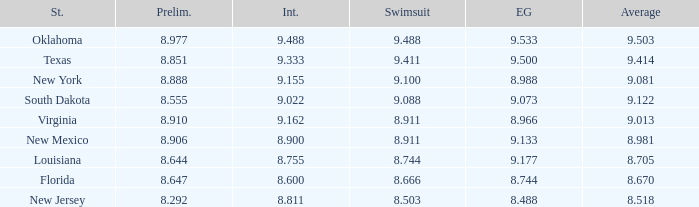 what's the evening gown where state is south dakota 9.073. 